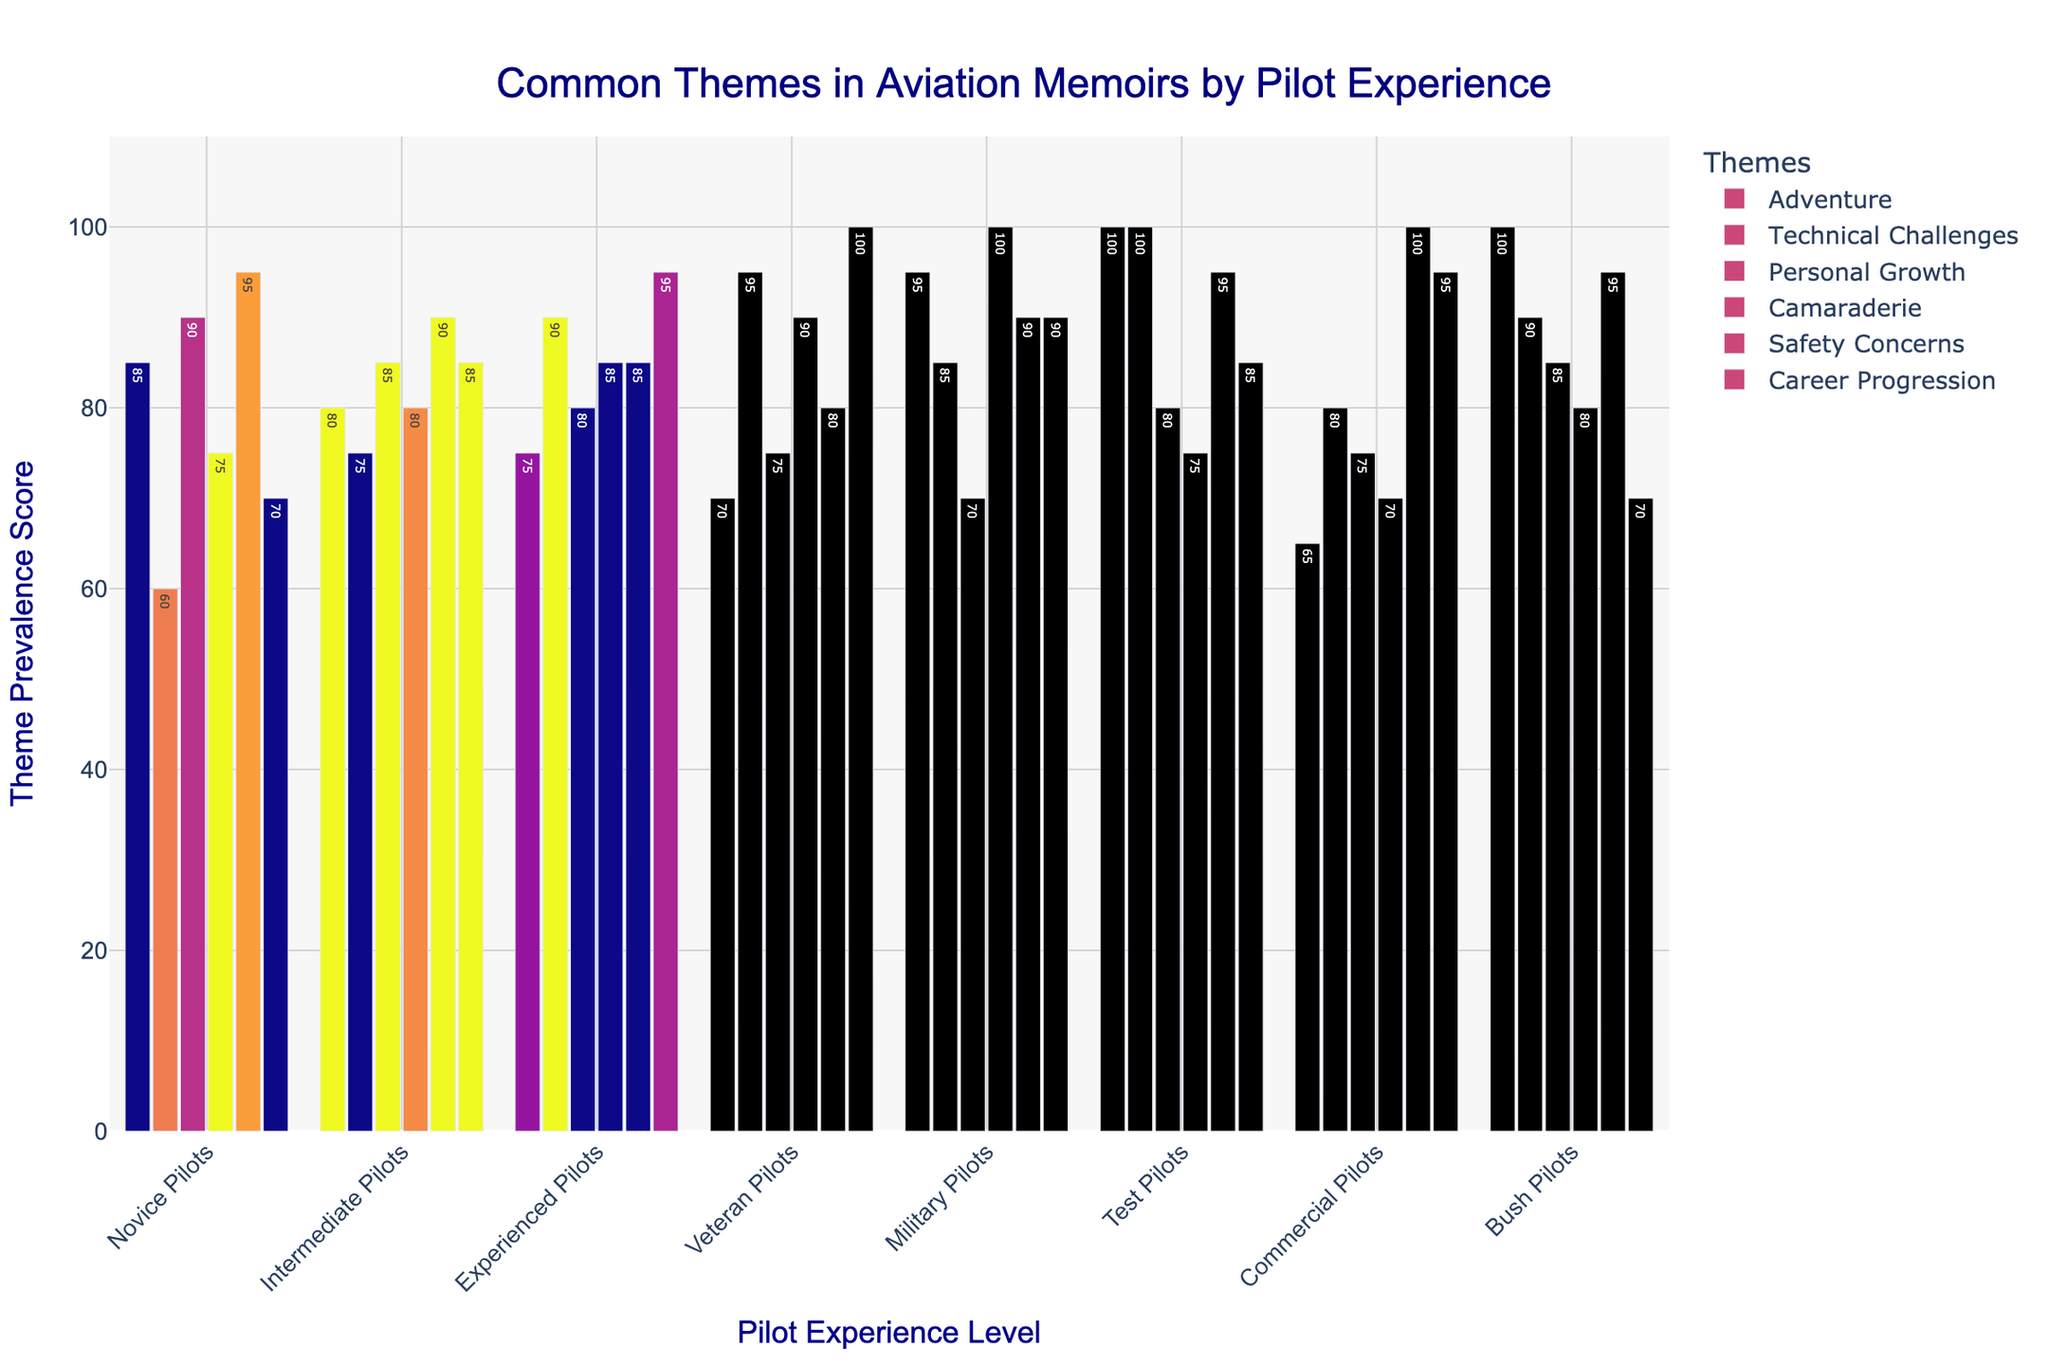Which pilot experience level has the highest prevalence score for the theme "Adventure"? To find the highest prevalence score for "Adventure", look at the "Adventure" bar for each experience level and identify the tallest bar. The tallest bar for "Adventure" is associated with Test Pilots.
Answer: Test Pilots Which pilot experience level shows the lowest score for the theme "Camaraderie"? To determine the lowest score for "Camaraderie", observe the "Camaraderie" bars and identify the shortest one. The shortest "Camaraderie" bar is for Commercial Pilots.
Answer: Commercial Pilots What is the average prevalence score for the theme "Career Progression" across all pilot experience levels? Add up the prevalence scores for "Career Progression" for all pilot experience levels (70 + 85 + 95 + 100 + 90 + 85 + 95 + 70) and divide by the number of experience levels, which is 8. Thus, (70 + 85 + 95 + 100 + 90 + 85 + 95 + 70) / 8 = 86.25.
Answer: 86.25 Which theme shows the greatest variation in scores between Novice Pilots and Veteran Pilots? Calculate the absolute differences in scores for each theme between Novice Pilots and Veteran Pilots: Adventure (85-70), Technical Challenges (60-95), Personal Growth (90-75), Camaraderie (75-90), Safety Concerns (95-80), Career Progression (70-100). The greatest difference is for "Technical Challenges" with a difference of 35.
Answer: Technical Challenges In which theme do Military Pilots and Bush Pilots have the same prevalence score? Look for themes where the bars for Military Pilots and Bush Pilots are equal in height. For "Camaraderie", both groups have a score of 100.
Answer: Camaraderie How do the scores of "Safety Concerns" for Novice Pilots and Experienced Pilots compare? Compare the heights of the "Safety Concerns" bars for Novice Pilots and Experienced Pilots. Novice Pilots have a score of 95, and Experienced Pilots have a score of 85. Thus, Novice Pilots have a higher score.
Answer: Novice Pilots have a higher score What is the total prevalence score for "Technical Challenges" across all pilot experience levels? Sum the scores for "Technical Challenges" for each experience level: 60 + 75 + 90 + 95 + 85 + 100 + 80 + 90 = 675.
Answer: 675 Which theme is equally prevalent among Novice Pilots and Intermediate Pilots? Look for themes where the bars for Novice Pilots and Intermediate Pilots are the same height. For "Personal Growth", both groups score 90.
Answer: Personal Growth 